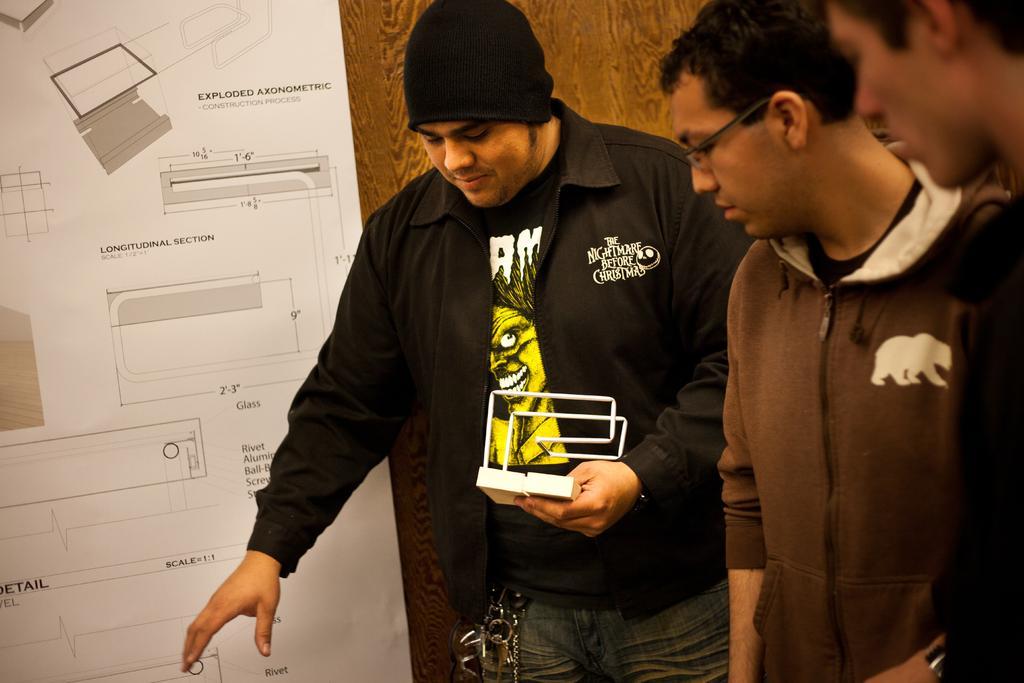How would you summarize this image in a sentence or two? In this image there are three persons standing , a person holding an object, and at the background there is a paper stick to the wooden wall. 